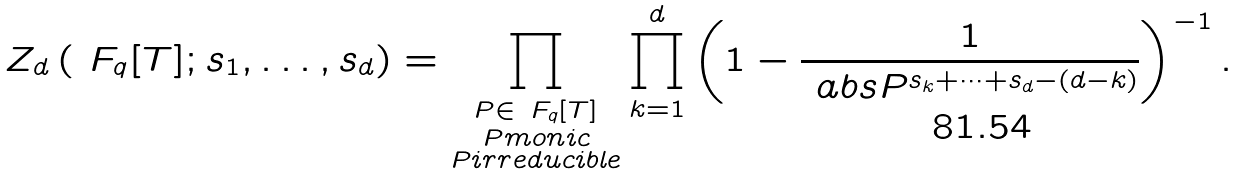Convert formula to latex. <formula><loc_0><loc_0><loc_500><loc_500>Z _ { d } \left ( \ F _ { q } [ T ] ; s _ { 1 } , \dots , s _ { d } \right ) = \prod _ { \substack { P \in \ F _ { q } [ T ] \\ P m o n i c \\ P i r r e d u c i b l e } } \prod _ { k = 1 } ^ { d } \left ( 1 - \frac { 1 } { \ a b s { P } ^ { s _ { k } + \cdots + s _ { d } - ( d - k ) } } \right ) ^ { - 1 } .</formula> 